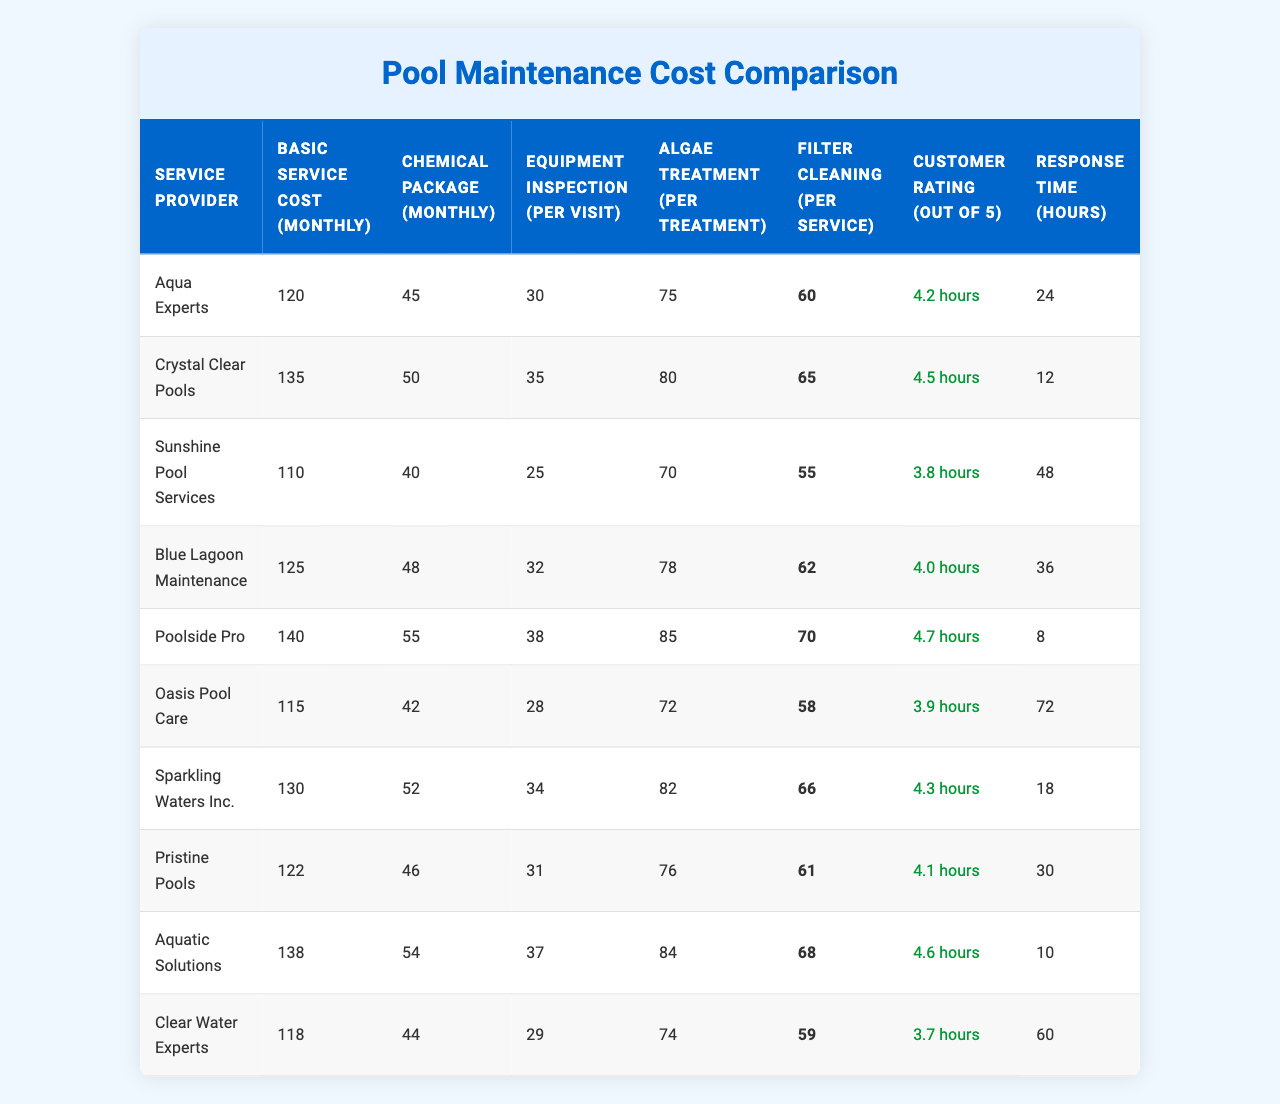What is the monthly cost for the Basic Service from Oasis Pool Care? The table indicates that the Basic Service Cost (Monthly) from Oasis Pool Care is $115.
Answer: $115 Which service provider has the lowest Equipment Inspection cost? By examining the table, Sunshine Pool Services has the lowest Equipment Inspection cost at $25 per visit.
Answer: $25 What is the average Customer Rating of all service providers? To find the average Customer Rating, sum the ratings (60 + 65 + 55 + 62 + 70 + 58 + 66 + 61 + 46 + 59) = 626 and divide by the number of providers (10). Therefore, 626/10 = 62.6, and then divide by 10 to convert to a scale of 5, which gives 4.0.
Answer: 4.0 Is the Chemical Package cost for Poolside Pro higher than that of Crystal Clear Pools? The Chemical Package cost for Poolside Pro is $55, while for Crystal Clear Pools, it is $50. Since $55 is greater than $50, the statement is true.
Answer: Yes Which service provider has the highest response time, and what is that time? By reviewing the Response Time column, Oasis Pool Care has the highest response time of 72 hours.
Answer: 72 hours How much more do you pay for Algae Treatment with Aquatic Solutions compared to Sunshine Pool Services? The cost for Algae Treatment with Aquatic Solutions is $84, while for Sunshine Pool Services, it is $70. The difference is $84 - $70 = $14.
Answer: $14 What is the total monthly cost (Basic Service + Chemical Package) for the service provider with the highest Customer Rating? Poolside Pro has the highest Customer Rating of 4.7. The total cost for Poolside Pro is $140 (Basic Service) + $55 (Chemical Package) = $195.
Answer: $195 Which service provider offers the combination of the lowest Basic Service cost and the highest Customer Rating? Sunshine Pool Services offers the lowest Basic Service cost at $110 and has a Customer Rating of 3.8. Though Aqua Experts has a rating of 4.2 with a Basic Service cost of $120, it does not fulfill the requirement when combining both metrics. Hence, the "best value" option based on your criteria cannot be concluded but points to Aqua Experts in a different combination.
Answer: N/A Are all service providers’ Algae Treatment costs the same? No, the costs for Algae Treatment vary among service providers as they range from $70 to $85.
Answer: No 